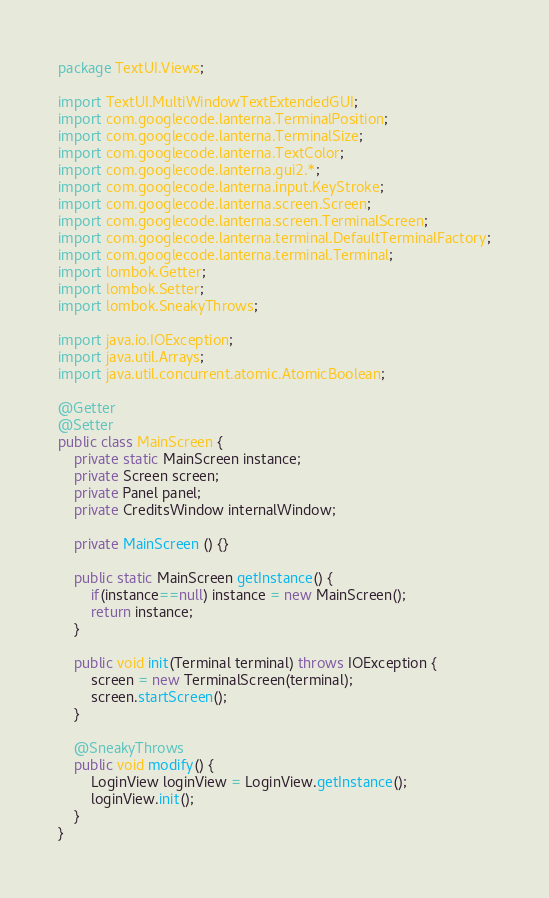Convert code to text. <code><loc_0><loc_0><loc_500><loc_500><_Java_>package TextUI.Views;

import TextUI.MultiWindowTextExtendedGUI;
import com.googlecode.lanterna.TerminalPosition;
import com.googlecode.lanterna.TerminalSize;
import com.googlecode.lanterna.TextColor;
import com.googlecode.lanterna.gui2.*;
import com.googlecode.lanterna.input.KeyStroke;
import com.googlecode.lanterna.screen.Screen;
import com.googlecode.lanterna.screen.TerminalScreen;
import com.googlecode.lanterna.terminal.DefaultTerminalFactory;
import com.googlecode.lanterna.terminal.Terminal;
import lombok.Getter;
import lombok.Setter;
import lombok.SneakyThrows;

import java.io.IOException;
import java.util.Arrays;
import java.util.concurrent.atomic.AtomicBoolean;

@Getter
@Setter
public class MainScreen {
    private static MainScreen instance;
    private Screen screen;
    private Panel panel;
    private CreditsWindow internalWindow;

    private MainScreen () {}

    public static MainScreen getInstance() {
        if(instance==null) instance = new MainScreen();
        return instance;
    }

    public void init(Terminal terminal) throws IOException {
        screen = new TerminalScreen(terminal);
        screen.startScreen();
    }

    @SneakyThrows
    public void modify() {
        LoginView loginView = LoginView.getInstance();
        loginView.init();
    }
}
</code> 